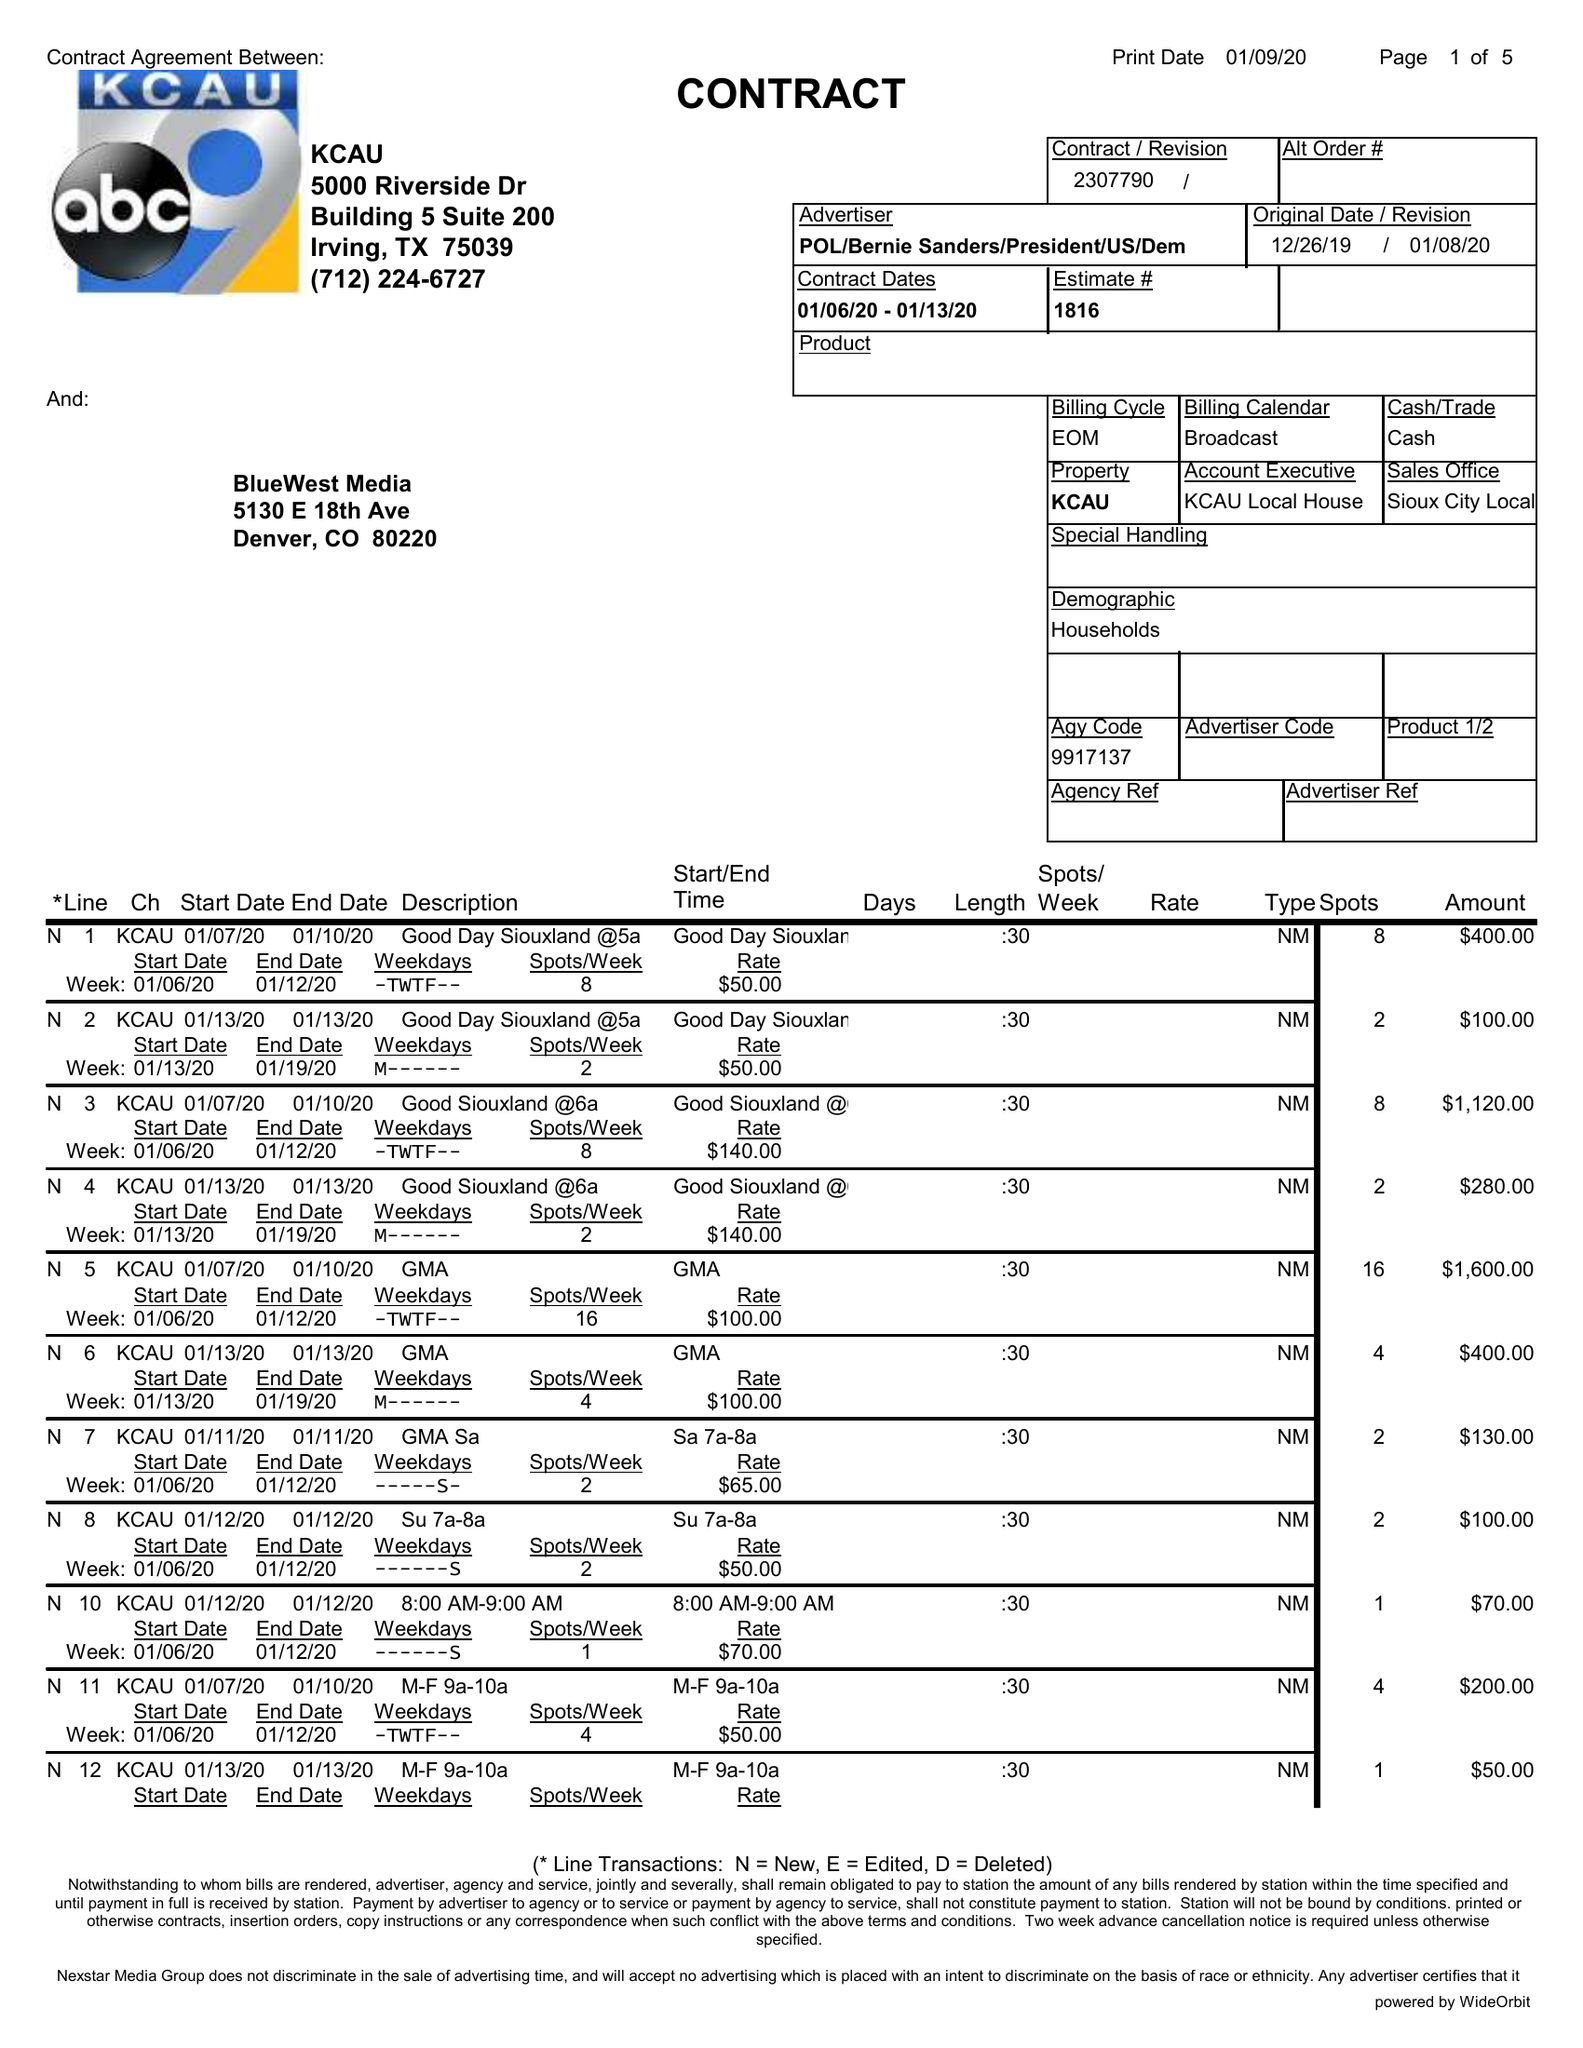What is the value for the flight_from?
Answer the question using a single word or phrase. 01/06/20 